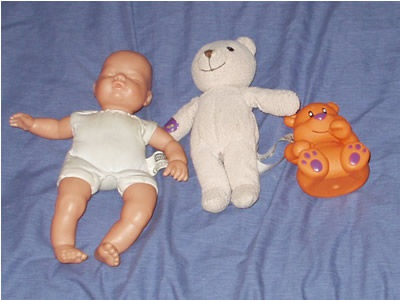Describe the objects in this image and their specific colors. I can see bed in gray, lightgray, and tan tones, teddy bear in ivory, lightgray, and darkgray tones, and teddy bear in ivory, red, orange, and brown tones in this image. 